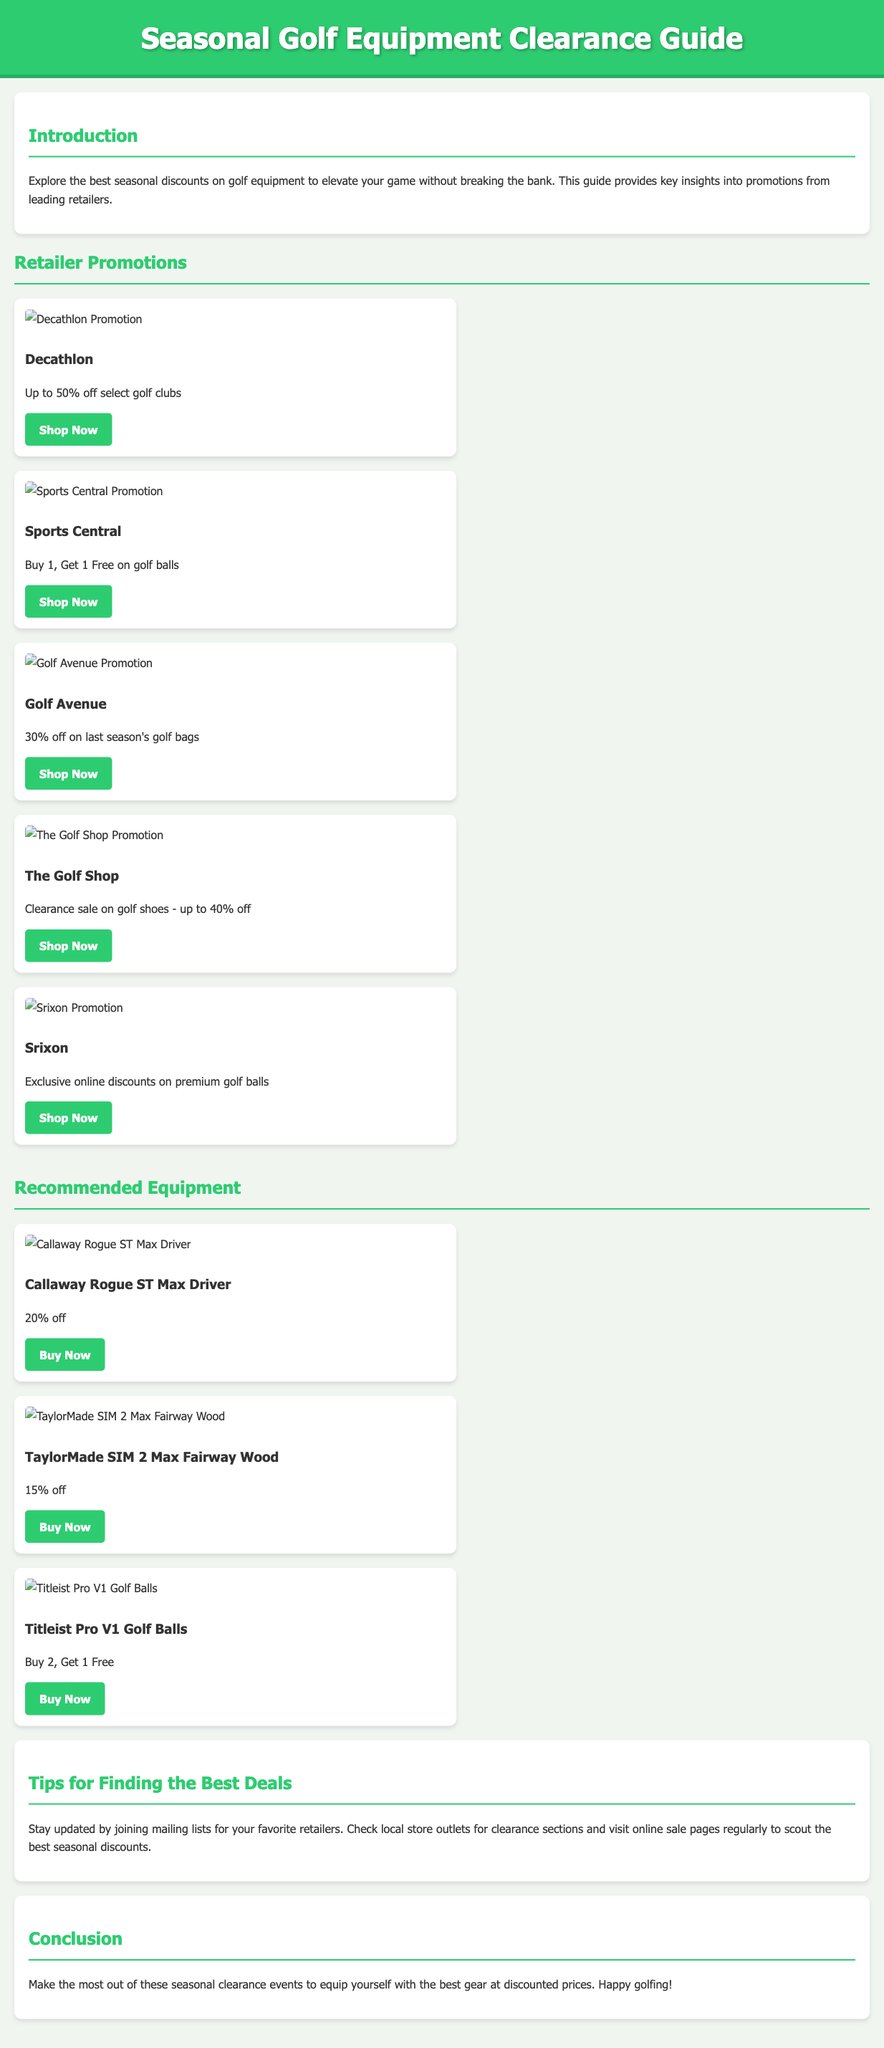What is the maximum discount offered by Decathlon? The document states that Decathlon offers up to 50% off select golf clubs.
Answer: 50% What promotional offer does Sports Central have? According to the document, Sports Central has a "Buy 1, Get 1 Free on golf balls" promotion.
Answer: Buy 1, Get 1 Free Which retailer has a sale on last season's golf bags? The document mentions that Golf Avenue has a 30% off sale on last season's golf bags.
Answer: Golf Avenue What is the discount on the Callaway Rogue ST Max Driver? The document specifies that the Callaway Rogue ST Max Driver is offered at 20% off.
Answer: 20% How much off is offered on TaylorMade SIM 2 Max Fairway Wood? The document indicates that the TaylorMade SIM 2 Max Fairway Wood has a 15% off discount.
Answer: 15% What is a suggested tip for finding best deals? The document advises staying updated by joining mailing lists for favorite retailers.
Answer: Joining mailing lists What type of golf balls does Titleist promote? The document shows that Titleist promotes "Buy 2, Get 1 Free" on Pro V1 Golf Balls.
Answer: Buy 2, Get 1 Free What color is the header background? The header background color is specified as green (#2ecc71) in the document.
Answer: Green What is the purpose of this guide? The document states that the guide provides key insights into promotions from leading retailers for seasonal golf equipment.
Answer: Insights into promotions 